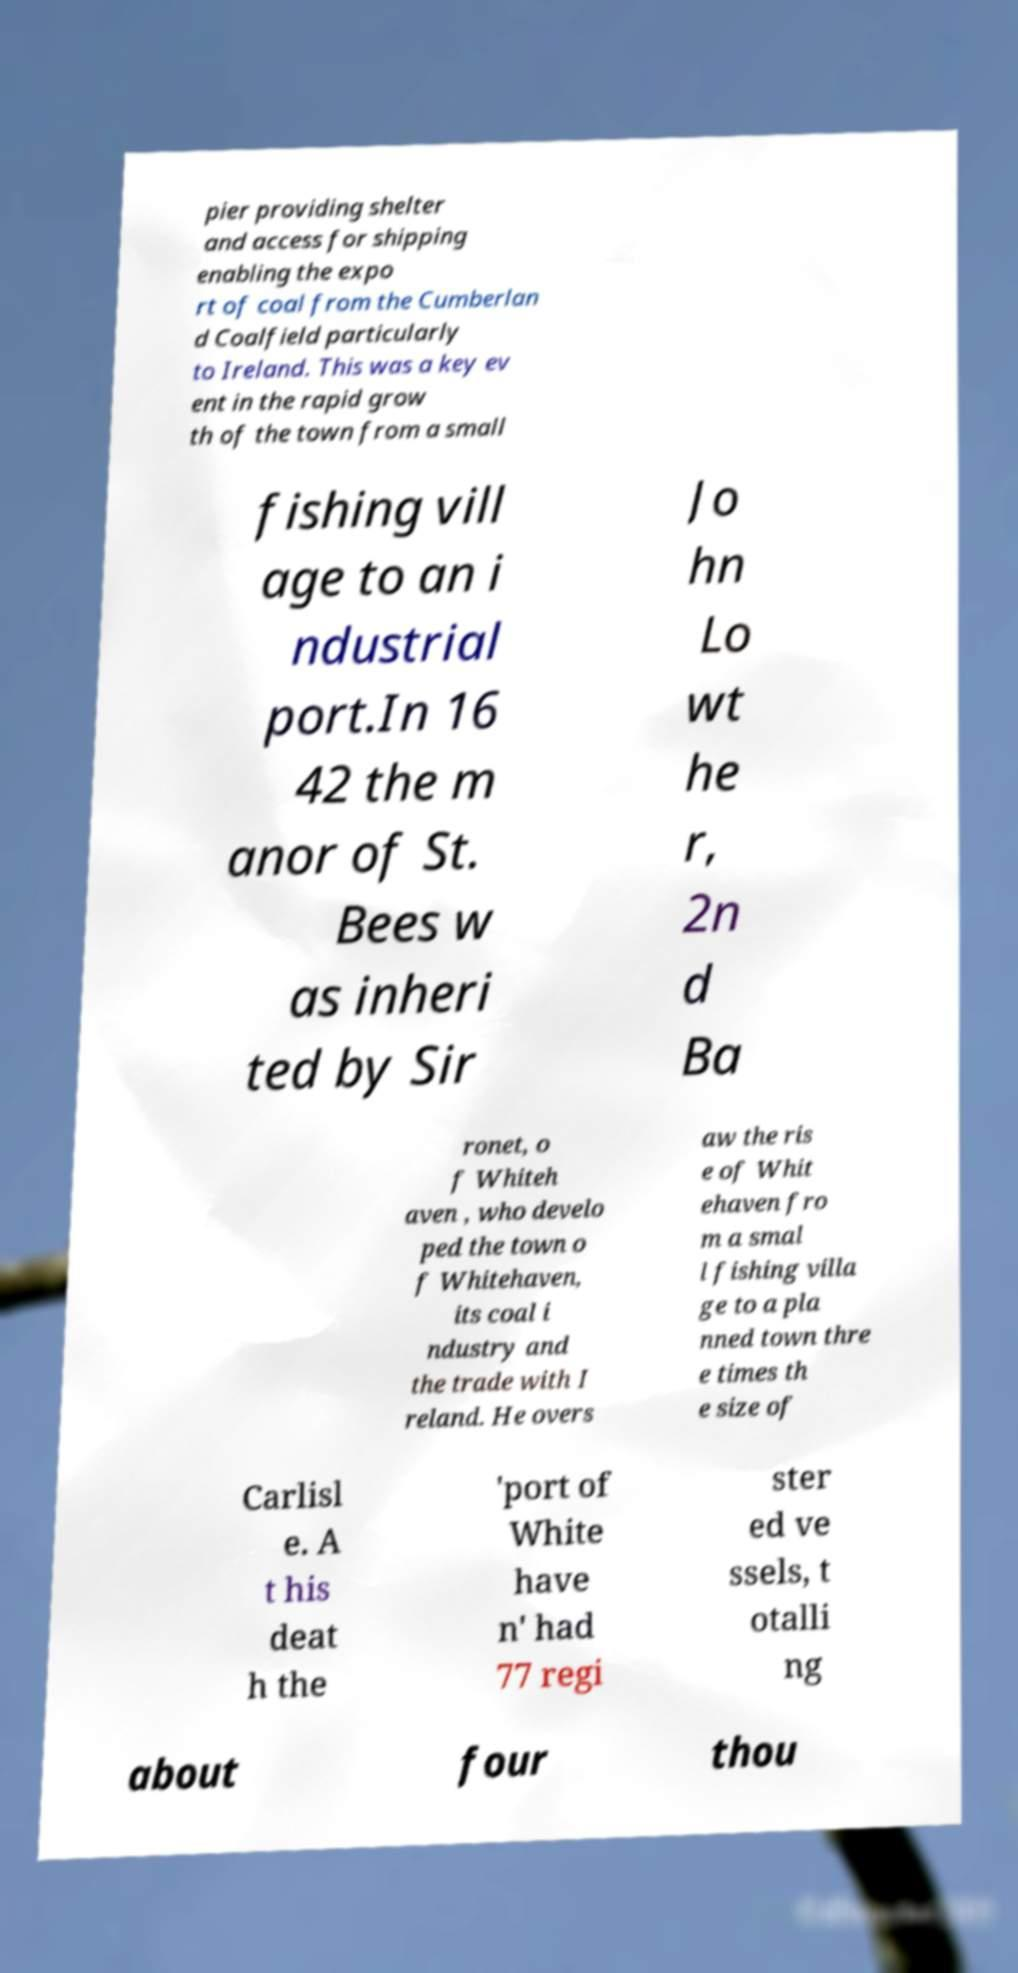Please read and relay the text visible in this image. What does it say? pier providing shelter and access for shipping enabling the expo rt of coal from the Cumberlan d Coalfield particularly to Ireland. This was a key ev ent in the rapid grow th of the town from a small fishing vill age to an i ndustrial port.In 16 42 the m anor of St. Bees w as inheri ted by Sir Jo hn Lo wt he r, 2n d Ba ronet, o f Whiteh aven , who develo ped the town o f Whitehaven, its coal i ndustry and the trade with I reland. He overs aw the ris e of Whit ehaven fro m a smal l fishing villa ge to a pla nned town thre e times th e size of Carlisl e. A t his deat h the 'port of White have n' had 77 regi ster ed ve ssels, t otalli ng about four thou 